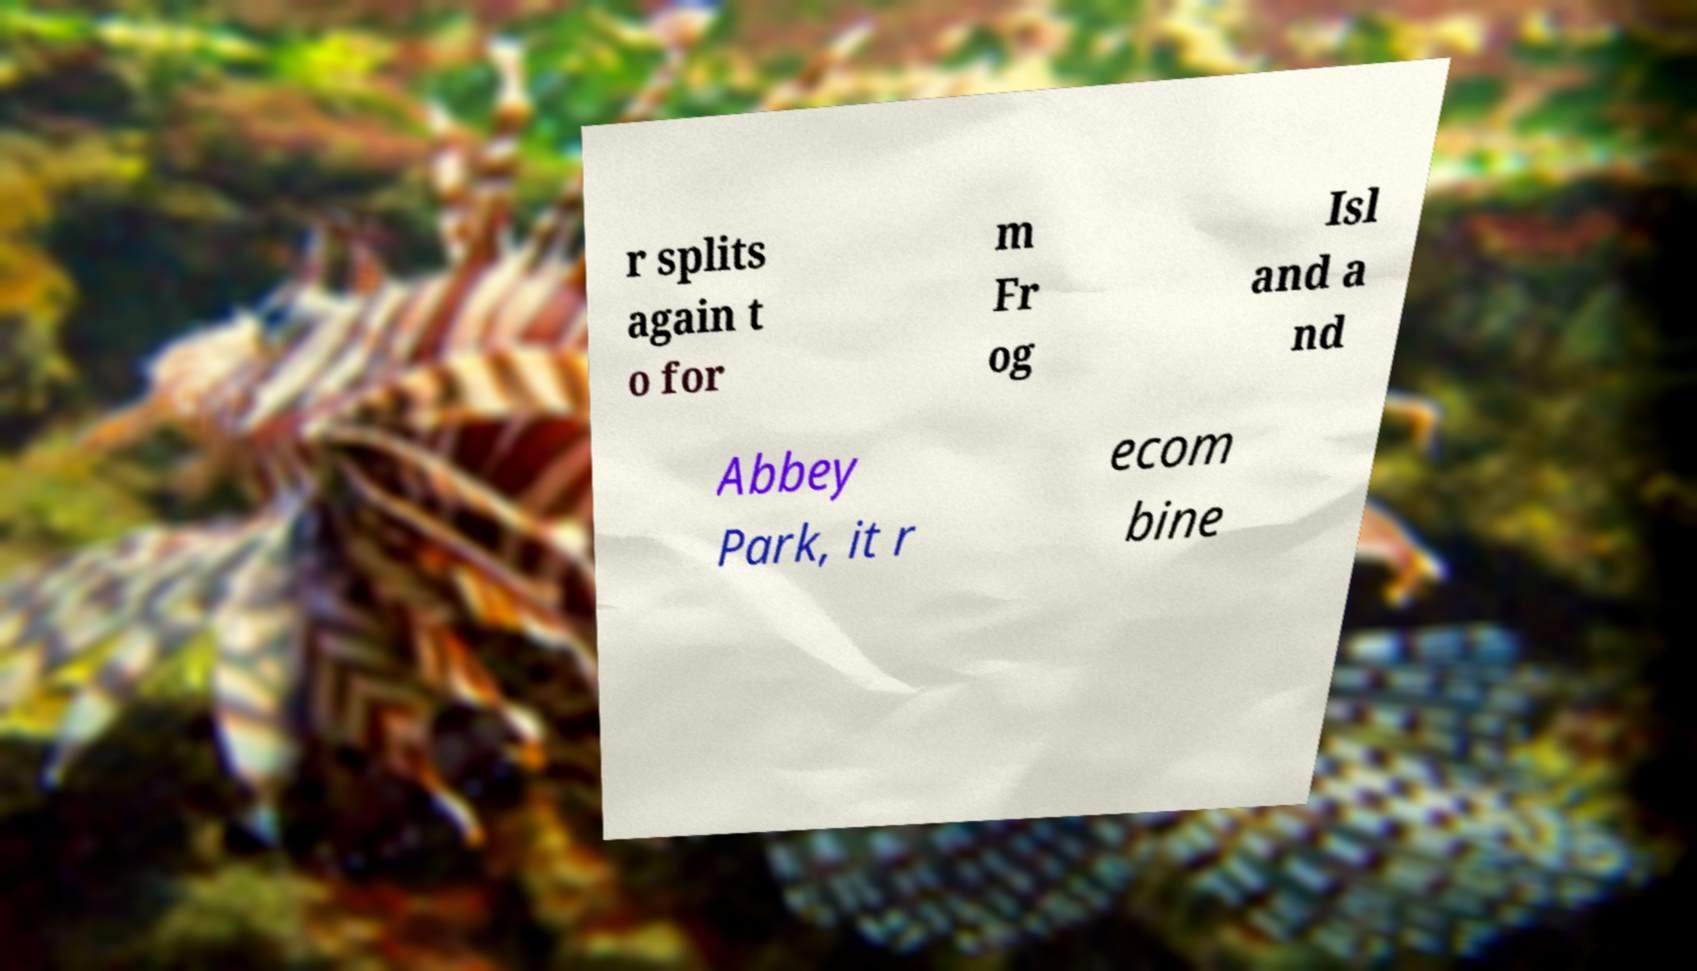Please identify and transcribe the text found in this image. r splits again t o for m Fr og Isl and a nd Abbey Park, it r ecom bine 